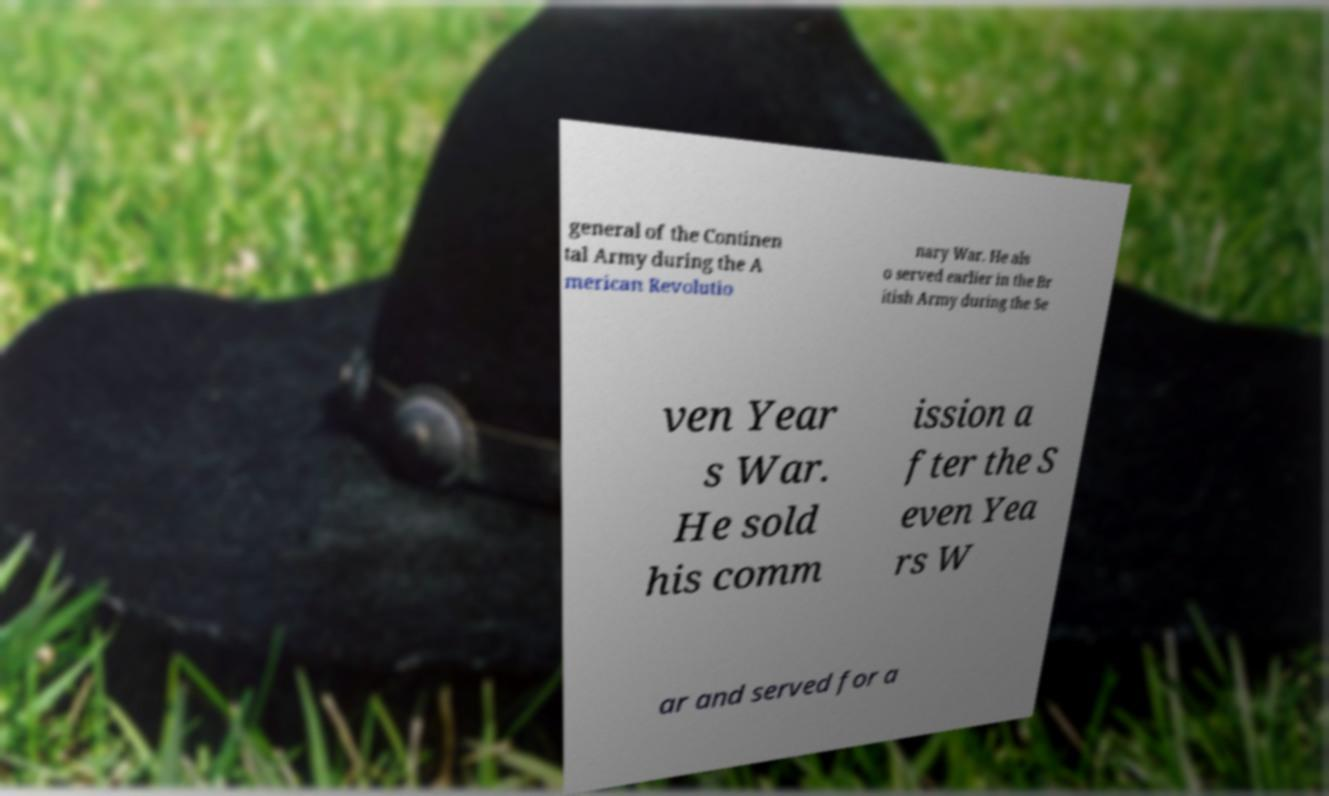Please identify and transcribe the text found in this image. general of the Continen tal Army during the A merican Revolutio nary War. He als o served earlier in the Br itish Army during the Se ven Year s War. He sold his comm ission a fter the S even Yea rs W ar and served for a 